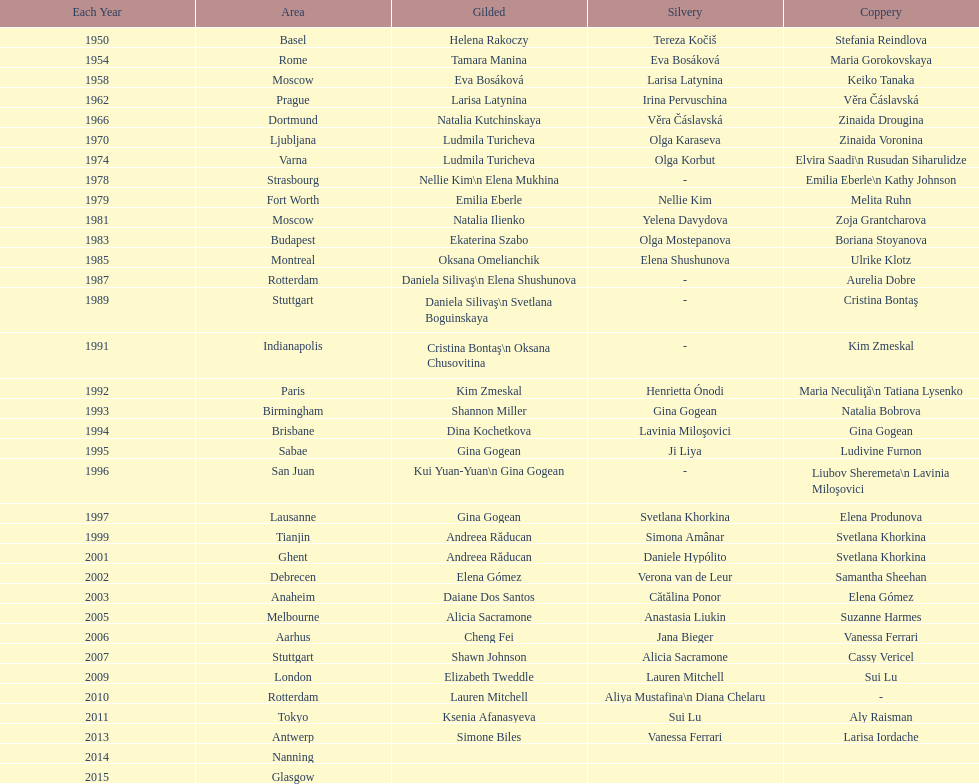How many times was the location in the united states? 3. 